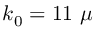Convert formula to latex. <formula><loc_0><loc_0><loc_500><loc_500>k _ { 0 } = 1 1 \mu</formula> 